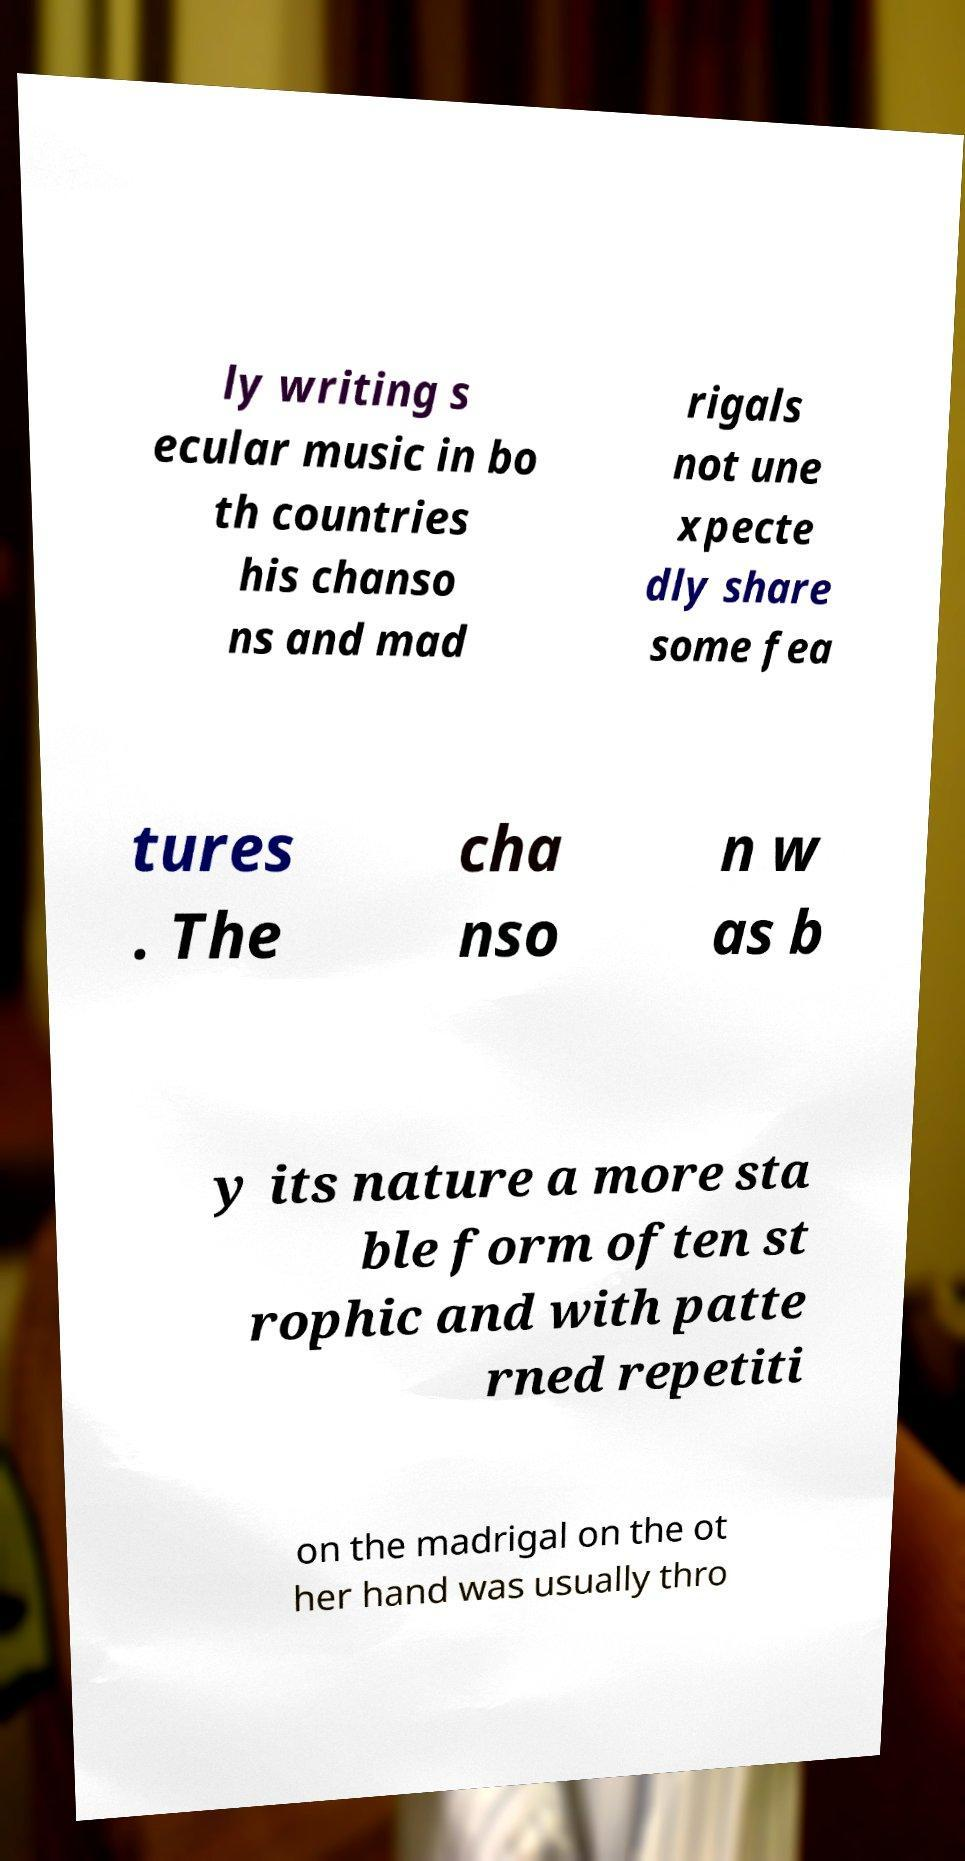I need the written content from this picture converted into text. Can you do that? ly writing s ecular music in bo th countries his chanso ns and mad rigals not une xpecte dly share some fea tures . The cha nso n w as b y its nature a more sta ble form often st rophic and with patte rned repetiti on the madrigal on the ot her hand was usually thro 